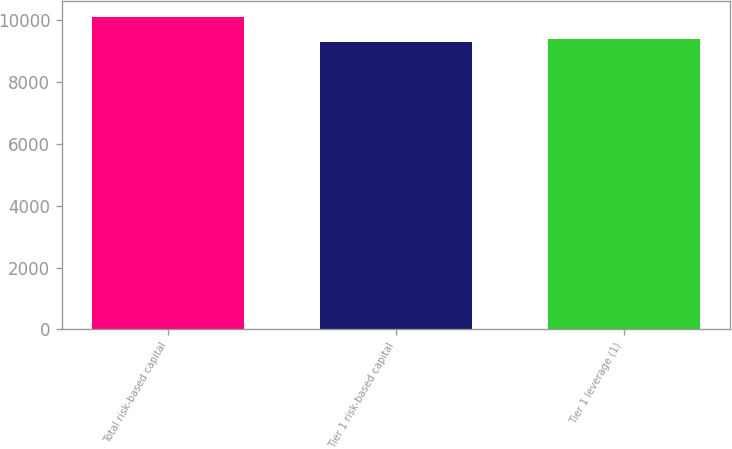Convert chart. <chart><loc_0><loc_0><loc_500><loc_500><bar_chart><fcel>Total risk-based capital<fcel>Tier 1 risk-based capital<fcel>Tier 1 leverage (1)<nl><fcel>10106<fcel>9297<fcel>9377.9<nl></chart> 